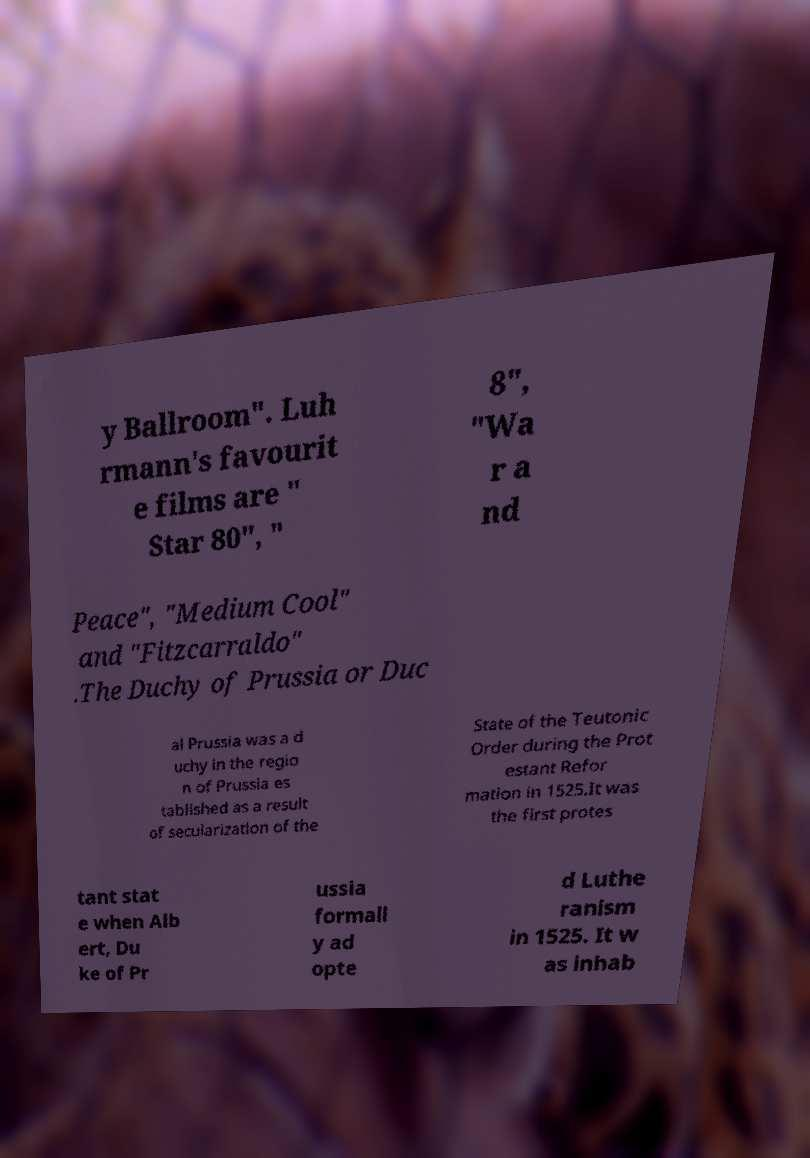Can you read and provide the text displayed in the image?This photo seems to have some interesting text. Can you extract and type it out for me? y Ballroom". Luh rmann's favourit e films are " Star 80", " 8", "Wa r a nd Peace", "Medium Cool" and "Fitzcarraldo" .The Duchy of Prussia or Duc al Prussia was a d uchy in the regio n of Prussia es tablished as a result of secularization of the State of the Teutonic Order during the Prot estant Refor mation in 1525.It was the first protes tant stat e when Alb ert, Du ke of Pr ussia formall y ad opte d Luthe ranism in 1525. It w as inhab 